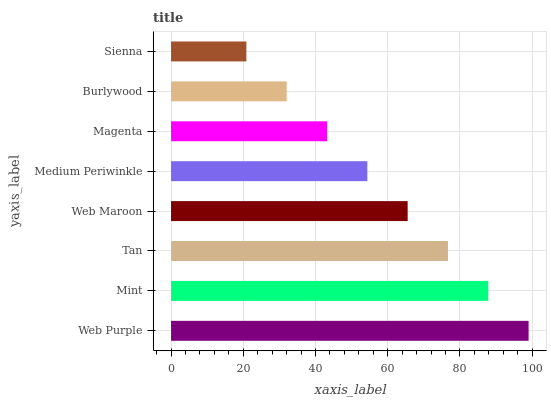Is Sienna the minimum?
Answer yes or no. Yes. Is Web Purple the maximum?
Answer yes or no. Yes. Is Mint the minimum?
Answer yes or no. No. Is Mint the maximum?
Answer yes or no. No. Is Web Purple greater than Mint?
Answer yes or no. Yes. Is Mint less than Web Purple?
Answer yes or no. Yes. Is Mint greater than Web Purple?
Answer yes or no. No. Is Web Purple less than Mint?
Answer yes or no. No. Is Web Maroon the high median?
Answer yes or no. Yes. Is Medium Periwinkle the low median?
Answer yes or no. Yes. Is Web Purple the high median?
Answer yes or no. No. Is Tan the low median?
Answer yes or no. No. 